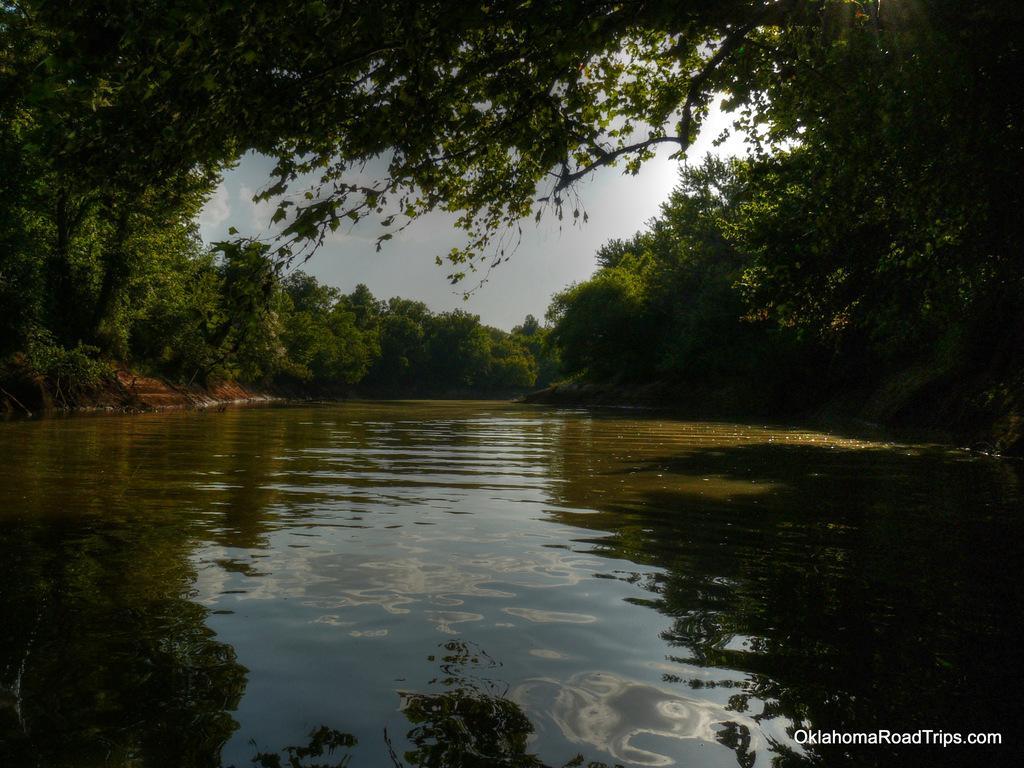In one or two sentences, can you explain what this image depicts? In the center of the image we can see the clouds are present in the sky. In the background of the image we can see the trees and water. In the bottom right corner we can see the text. 